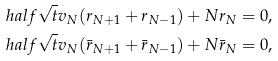Convert formula to latex. <formula><loc_0><loc_0><loc_500><loc_500>\ h a l f \sqrt { t } v _ { N } ( r _ { N + 1 } + r _ { N - 1 } ) + N r _ { N } & = 0 , \\ \ h a l f \sqrt { t } v _ { N } ( \bar { r } _ { N + 1 } + \bar { r } _ { N - 1 } ) + N \bar { r } _ { N } & = 0 ,</formula> 